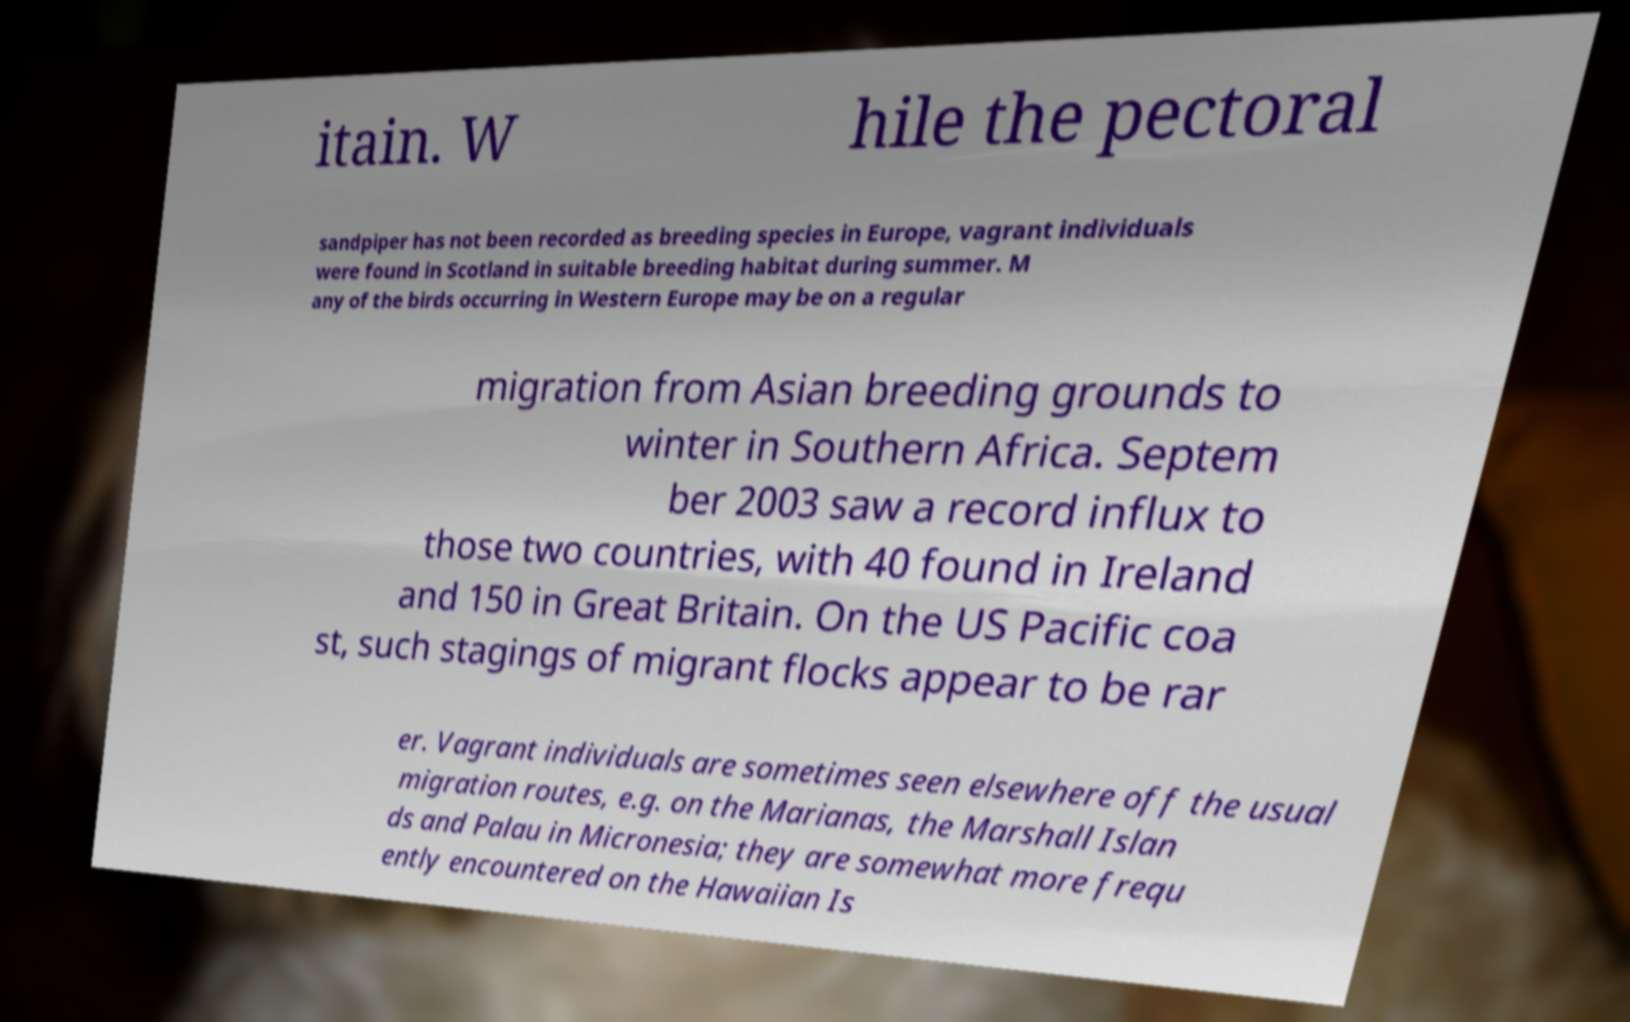Can you read and provide the text displayed in the image?This photo seems to have some interesting text. Can you extract and type it out for me? itain. W hile the pectoral sandpiper has not been recorded as breeding species in Europe, vagrant individuals were found in Scotland in suitable breeding habitat during summer. M any of the birds occurring in Western Europe may be on a regular migration from Asian breeding grounds to winter in Southern Africa. Septem ber 2003 saw a record influx to those two countries, with 40 found in Ireland and 150 in Great Britain. On the US Pacific coa st, such stagings of migrant flocks appear to be rar er. Vagrant individuals are sometimes seen elsewhere off the usual migration routes, e.g. on the Marianas, the Marshall Islan ds and Palau in Micronesia; they are somewhat more frequ ently encountered on the Hawaiian Is 